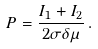<formula> <loc_0><loc_0><loc_500><loc_500>P = \frac { I _ { 1 } + I _ { 2 } } { 2 \sigma \delta \mu } \, .</formula> 